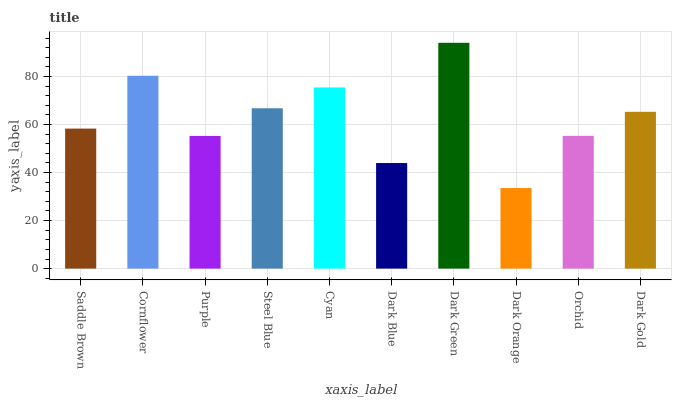Is Dark Orange the minimum?
Answer yes or no. Yes. Is Dark Green the maximum?
Answer yes or no. Yes. Is Cornflower the minimum?
Answer yes or no. No. Is Cornflower the maximum?
Answer yes or no. No. Is Cornflower greater than Saddle Brown?
Answer yes or no. Yes. Is Saddle Brown less than Cornflower?
Answer yes or no. Yes. Is Saddle Brown greater than Cornflower?
Answer yes or no. No. Is Cornflower less than Saddle Brown?
Answer yes or no. No. Is Dark Gold the high median?
Answer yes or no. Yes. Is Saddle Brown the low median?
Answer yes or no. Yes. Is Purple the high median?
Answer yes or no. No. Is Dark Gold the low median?
Answer yes or no. No. 